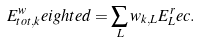Convert formula to latex. <formula><loc_0><loc_0><loc_500><loc_500>E _ { t o t , k } ^ { w } e i g h t e d & = \sum _ { L } w _ { k , L } E _ { L } ^ { r } e c .</formula> 